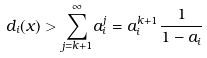<formula> <loc_0><loc_0><loc_500><loc_500>d _ { i } ( x ) > \overset { \infty } { \underset { j = k + 1 } { \sum } } a _ { i } ^ { j } = a _ { i } ^ { k + 1 } \frac { 1 } { 1 - a _ { i } }</formula> 